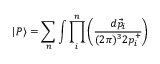Convert formula to latex. <formula><loc_0><loc_0><loc_500><loc_500>| P \rangle = \sum _ { n } \int \prod _ { i } ^ { n } \left ( \frac { d \vec { p } _ { i } } { ( 2 \pi ) ^ { 3 } 2 p _ { i } ^ { + } } \right )</formula> 